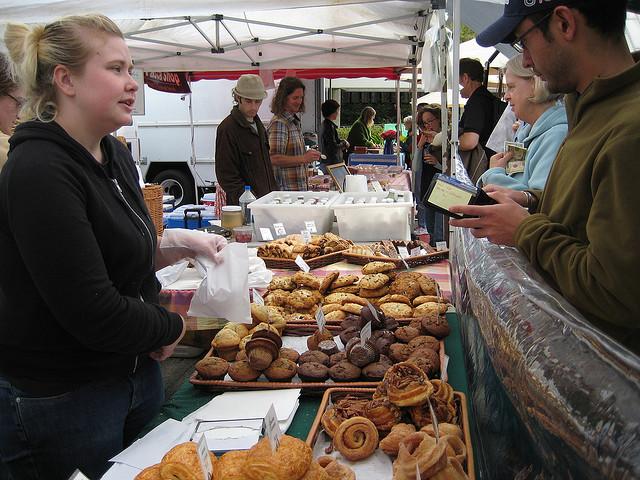Are all the people pictured of asian descent?
Answer briefly. No. What class of foods are these?
Give a very brief answer. Baked goods. Are pastries shown in the image?
Be succinct. Yes. Are there both fruits and vegetables on display?
Be succinct. No. 